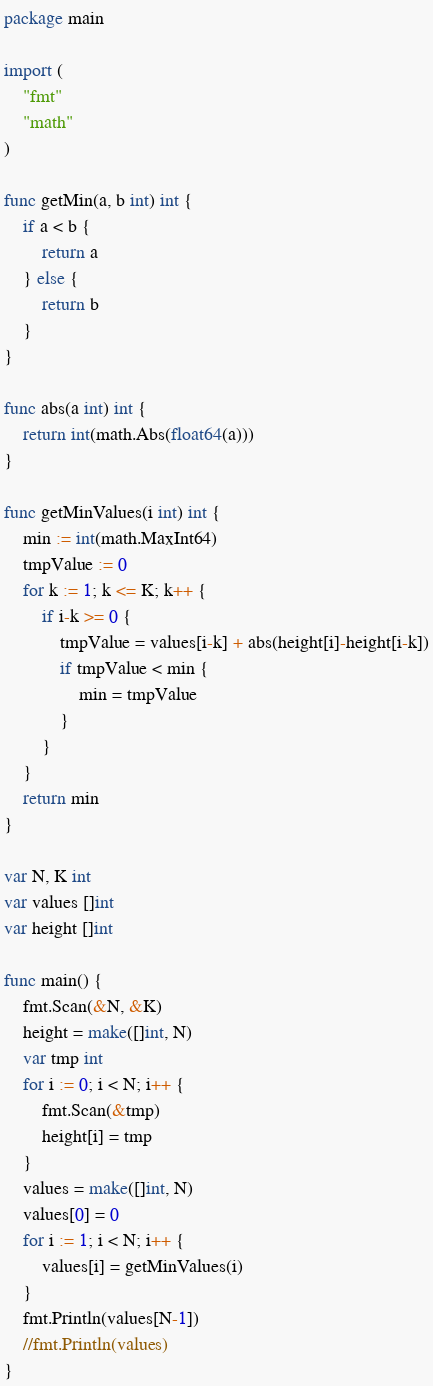<code> <loc_0><loc_0><loc_500><loc_500><_Go_>package main

import (
	"fmt"
	"math"
)

func getMin(a, b int) int {
	if a < b {
		return a
	} else {
		return b
	}
}

func abs(a int) int {
	return int(math.Abs(float64(a)))
}

func getMinValues(i int) int {
	min := int(math.MaxInt64)
	tmpValue := 0
	for k := 1; k <= K; k++ {
		if i-k >= 0 {
			tmpValue = values[i-k] + abs(height[i]-height[i-k])
			if tmpValue < min {
				min = tmpValue
			}
		}
	}
	return min
}

var N, K int
var values []int
var height []int

func main() {
	fmt.Scan(&N, &K)
	height = make([]int, N)
	var tmp int
	for i := 0; i < N; i++ {
		fmt.Scan(&tmp)
		height[i] = tmp
	}
	values = make([]int, N)
	values[0] = 0
	for i := 1; i < N; i++ {
		values[i] = getMinValues(i)
	}
	fmt.Println(values[N-1])
	//fmt.Println(values)
}
</code> 